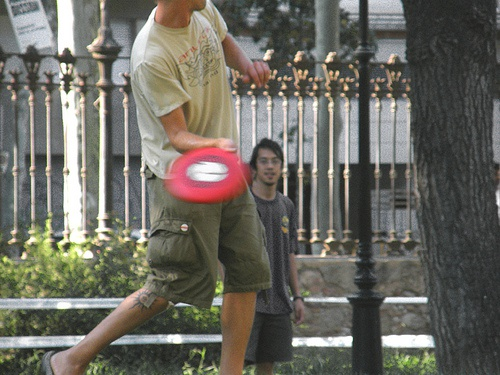Describe the objects in this image and their specific colors. I can see people in black, gray, darkgray, and tan tones, people in black and gray tones, and frisbee in black, salmon, lightgray, and brown tones in this image. 